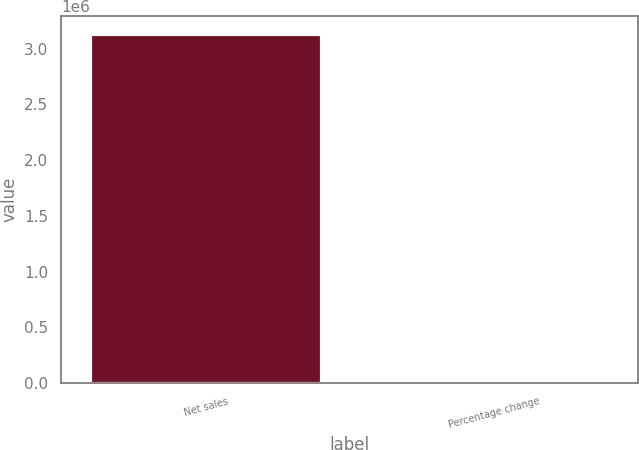<chart> <loc_0><loc_0><loc_500><loc_500><bar_chart><fcel>Net sales<fcel>Percentage change<nl><fcel>3.13358e+06<fcel>13.3<nl></chart> 